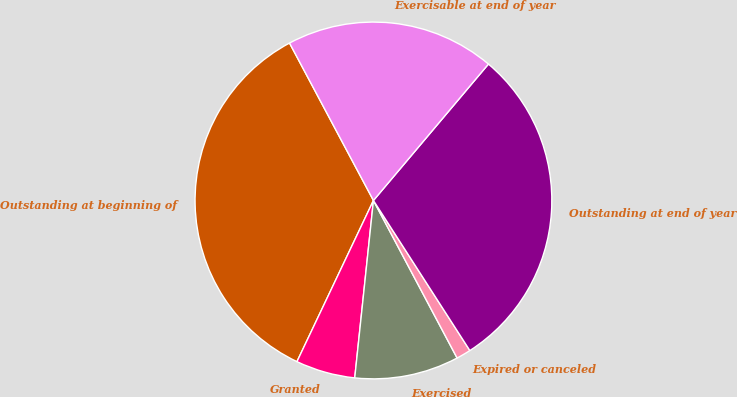Convert chart to OTSL. <chart><loc_0><loc_0><loc_500><loc_500><pie_chart><fcel>Outstanding at beginning of<fcel>Granted<fcel>Exercised<fcel>Expired or canceled<fcel>Outstanding at end of year<fcel>Exercisable at end of year<nl><fcel>35.15%<fcel>5.38%<fcel>9.44%<fcel>1.32%<fcel>29.76%<fcel>18.94%<nl></chart> 